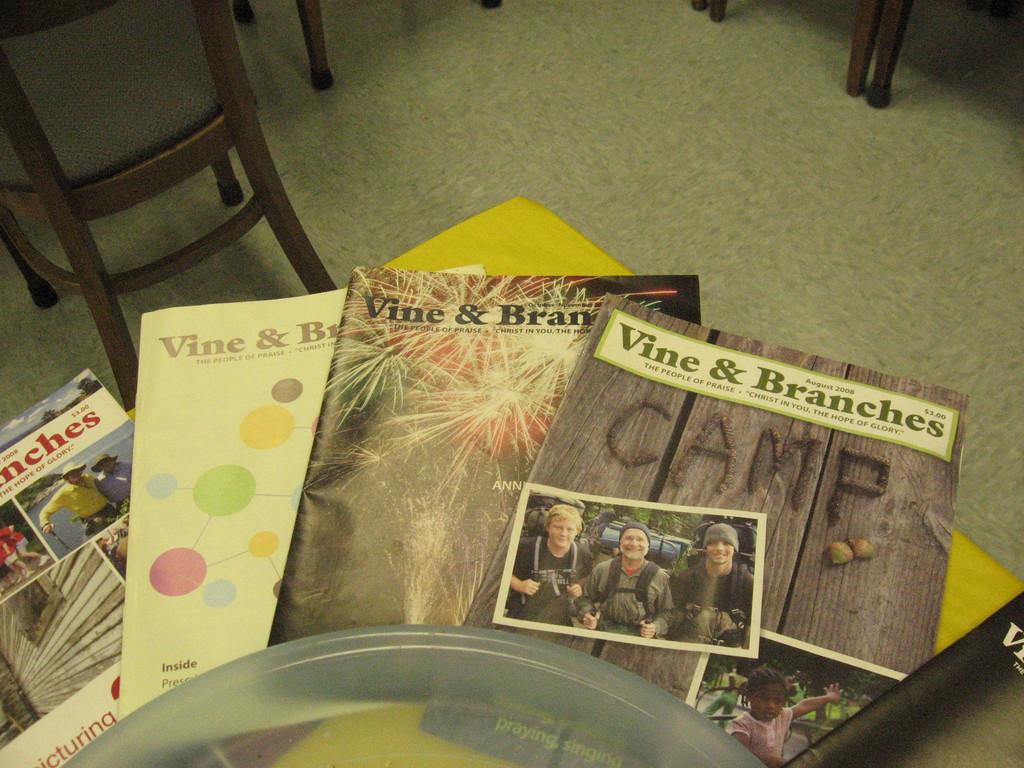<image>
Render a clear and concise summary of the photo. Four magazines titled Vine and Branch are on a table. 